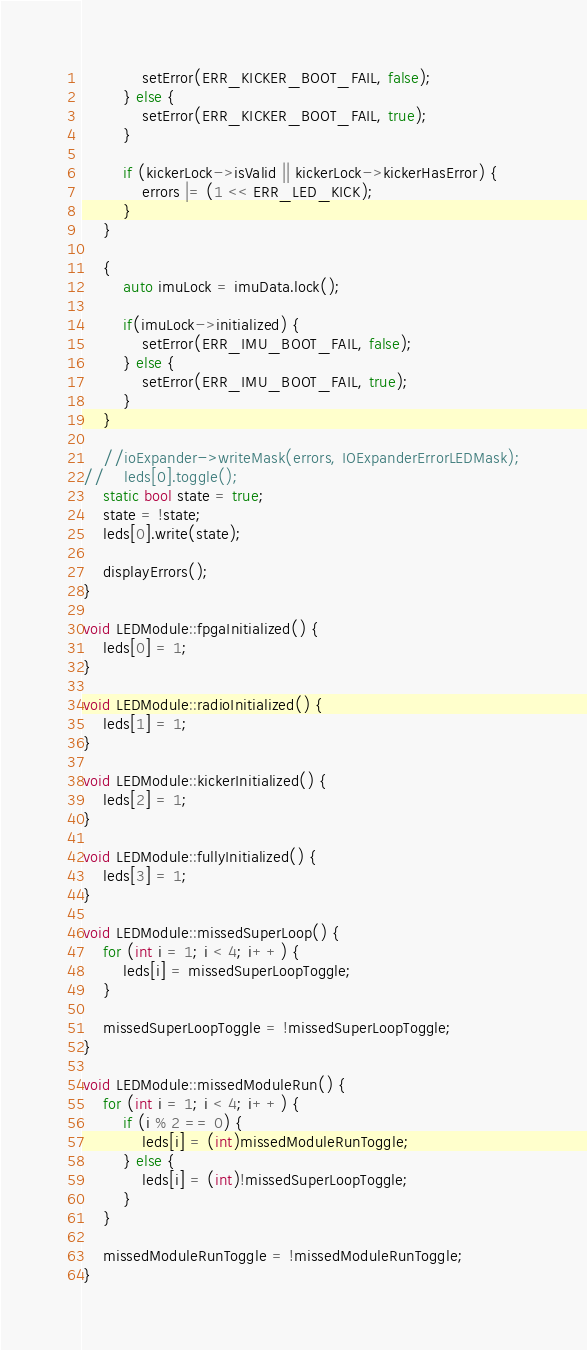<code> <loc_0><loc_0><loc_500><loc_500><_C++_>            setError(ERR_KICKER_BOOT_FAIL, false);
        } else {
            setError(ERR_KICKER_BOOT_FAIL, true);
        }

        if (kickerLock->isValid || kickerLock->kickerHasError) {
            errors |= (1 << ERR_LED_KICK);
        }
    }

    {
        auto imuLock = imuData.lock();

        if(imuLock->initialized) {
            setError(ERR_IMU_BOOT_FAIL, false);
        } else {
            setError(ERR_IMU_BOOT_FAIL, true);
        }
    }

    //ioExpander->writeMask(errors, IOExpanderErrorLEDMask);
//    leds[0].toggle();
    static bool state = true;
    state = !state;
    leds[0].write(state);

    displayErrors();
}

void LEDModule::fpgaInitialized() {
    leds[0] = 1;
}

void LEDModule::radioInitialized() {
    leds[1] = 1;
}

void LEDModule::kickerInitialized() {
    leds[2] = 1;
}

void LEDModule::fullyInitialized() {
    leds[3] = 1;
}

void LEDModule::missedSuperLoop() {
    for (int i = 1; i < 4; i++) {
        leds[i] = missedSuperLoopToggle;
    }

    missedSuperLoopToggle = !missedSuperLoopToggle;
}

void LEDModule::missedModuleRun() {
    for (int i = 1; i < 4; i++) {
        if (i % 2 == 0) {
            leds[i] = (int)missedModuleRunToggle;
        } else {
            leds[i] = (int)!missedSuperLoopToggle;
        }
    }

    missedModuleRunToggle = !missedModuleRunToggle;
}
</code> 